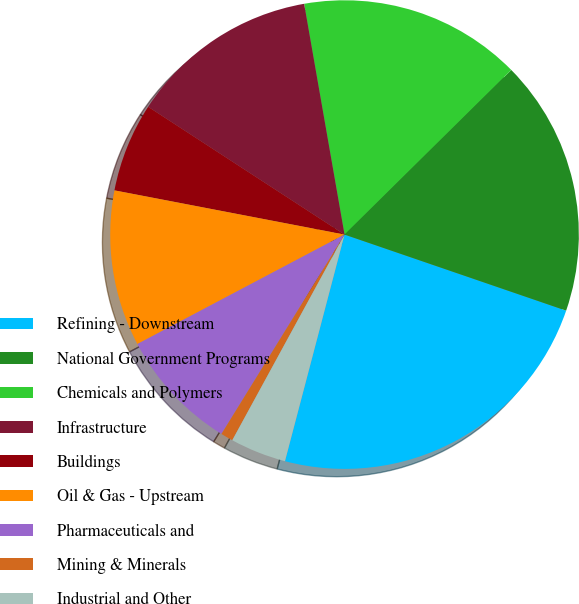Convert chart. <chart><loc_0><loc_0><loc_500><loc_500><pie_chart><fcel>Refining - Downstream<fcel>National Government Programs<fcel>Chemicals and Polymers<fcel>Infrastructure<fcel>Buildings<fcel>Oil & Gas - Upstream<fcel>Pharmaceuticals and<fcel>Mining & Minerals<fcel>Industrial and Other<nl><fcel>23.83%<fcel>17.66%<fcel>15.36%<fcel>13.06%<fcel>6.16%<fcel>10.76%<fcel>8.46%<fcel>0.85%<fcel>3.86%<nl></chart> 